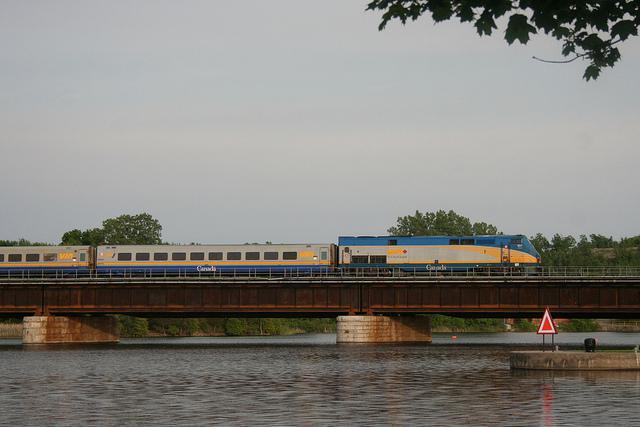How many people do you see?
Give a very brief answer. 0. How many cars long is the train?
Give a very brief answer. 3. How many cars does the train have?
Give a very brief answer. 3. How many trains are visible?
Give a very brief answer. 1. 